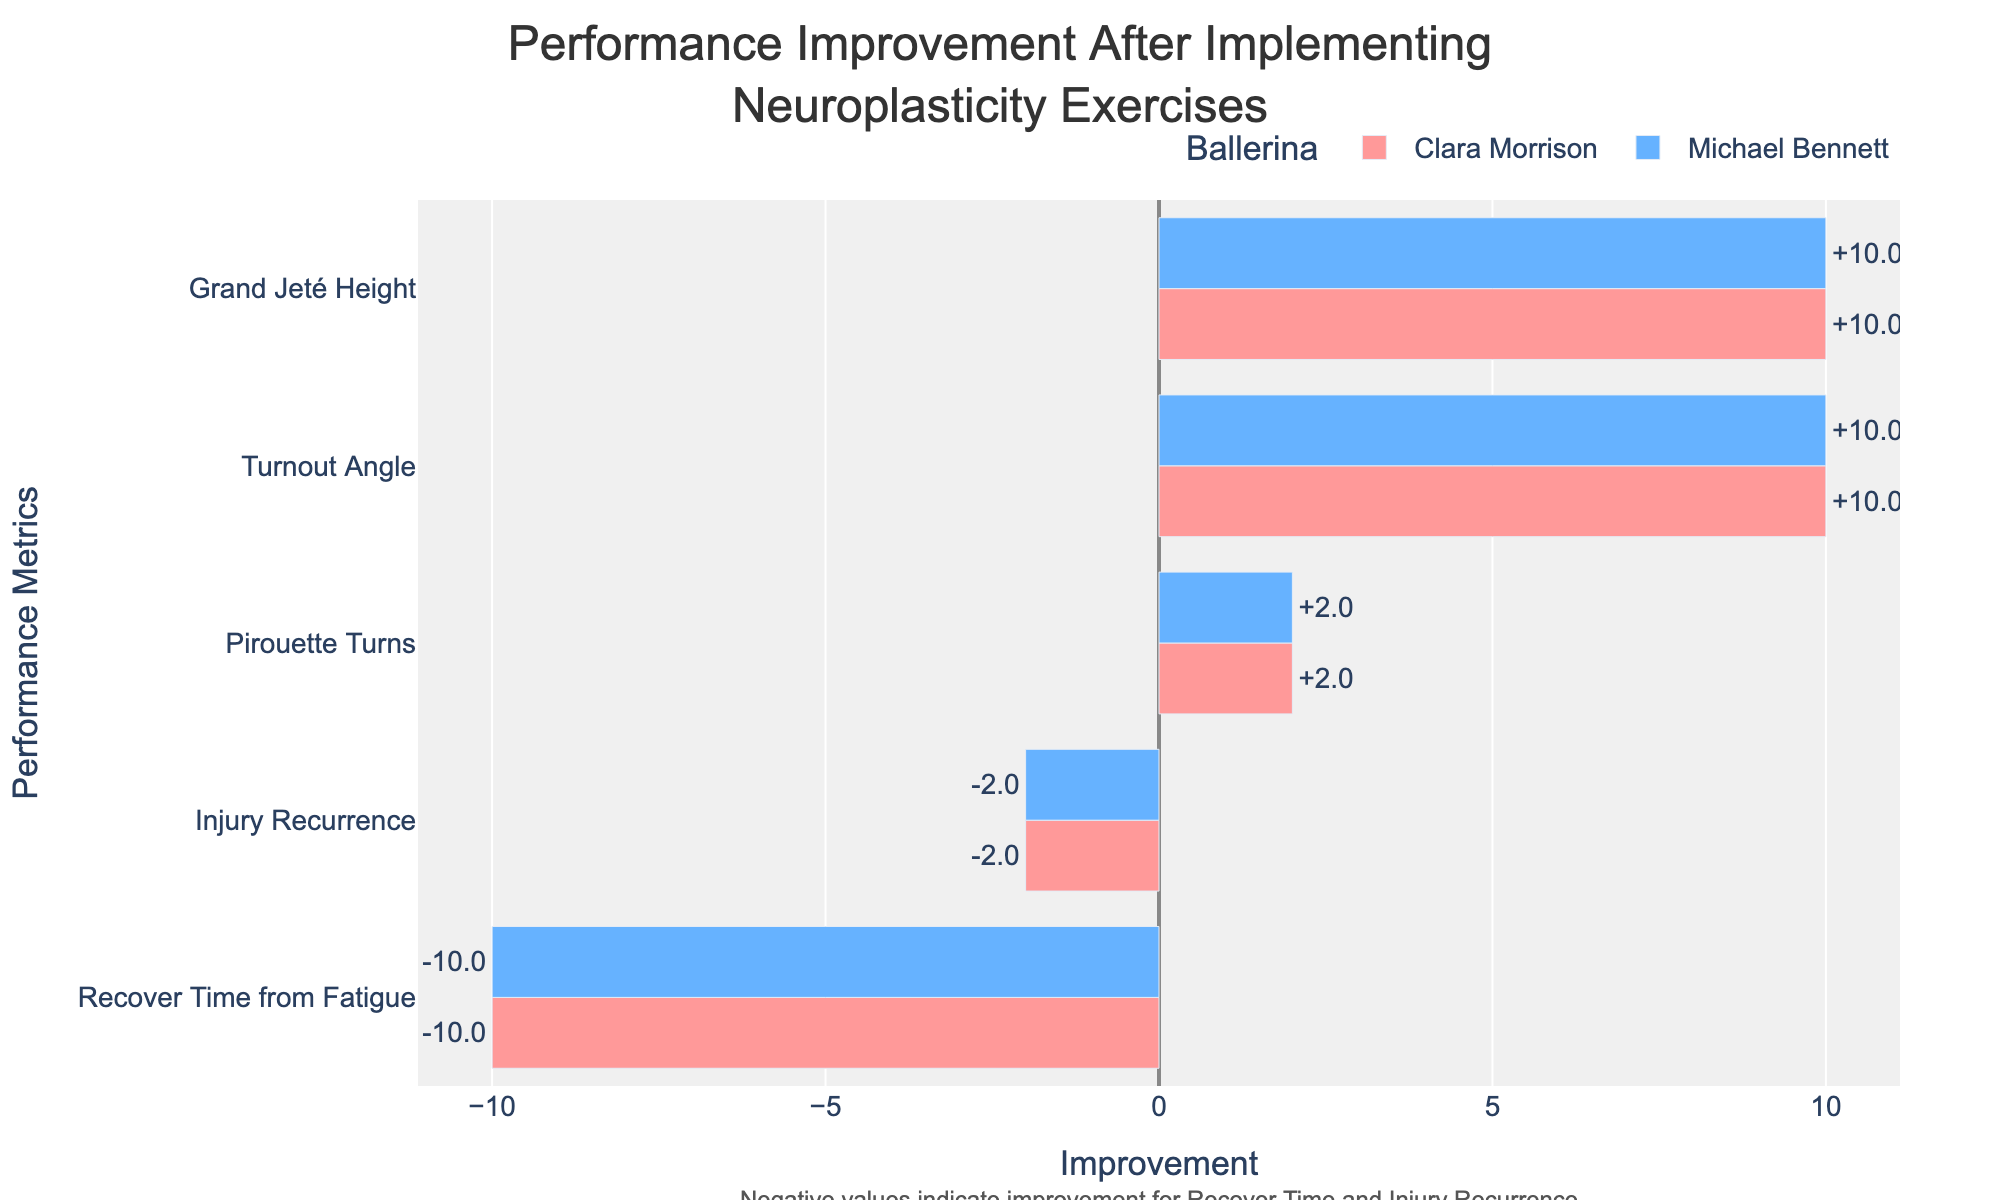Which ballerina showed the largest improvement in Turnout Angle? By looking at the difference in the Turnout Angle before and after implementing neuroplasticity exercises, Michael Bennett improved by 10 degrees (from 40 to 50 degrees), whereas Clara Morrison improved by 10 degrees (from 45 to 55 degrees). Both improved by the same amount.
Answer: Both showed the same improvement Which performance metric showed the highest average improvement for both ballerinas? Calculating the average improvement across all metrics, the Turnout Angle and Pirouette Turns both have an average improvement of 10 for Michael Bennett and Clara Morrison combined. However, the overall improvement can be seen visually by noting the highest bars.
Answer: Turnout Angle and Pirouette Turns What is the percentage improvement in Clara Morrison's Grand Jeté Height after implementing the exercises? Clara Morrison's Grand Jeté Height increased from 50 to 60. The percentage improvement is calculated as ((60 - 50) / 50) * 100 = 20%.
Answer: 20% Did Michael Bennett's recovery time from fatigue show an improvement or decline? By checking the bar chart, Michael Bennett’s recovery time from fatigue decreased from 28 to 18, indicating an improvement.
Answer: Improvement Which ballerina had a greater reduction in injury recurrence after implementing neuroplasticity exercises? Comparing the differences, Clara Morrison reduced her injury recurrence from 3 to 1, a reduction of 2 incidents. Michael Bennett reduced his injury recurrence from 4 to 2, also a reduction of 2 incidents. Both had the same reduction.
Answer: Both had the same reduction How much did Michael Bennett's Pirouette Turns improve after implementing the exercises? Michael Bennett's Pirouette Turns increased from 3 to 5. The improvement is thus 5 - 3 = 2 turns.
Answer: 2 turns Which performance metric showed the smallest improvement for Clara Morrison? By comparing the visual lengths of the bars for Clara Morrison, it is evident that the smallest improvement is in Injury Recurrence, which improved by 2 incidents.
Answer: Injury Recurrence Between Clara Morrison and Michael Bennett, who achieved a higher turnout angle after implementing the neuroplasticity exercises? The final turnout angle for Clara Morrison is 55 degrees and for Michael Bennett, it is 50 degrees. Therefore, Clara Morrison achieved a higher turnout angle.
Answer: Clara Morrison What is the total change in Clara Morrison's performance across all metrics after implementing neuroplasticity exercises? Summing the differences for Clara Morrison across all metrics: (55-45) + (4-2) + (60-50) + (30-20) + (3-1) = 10 + 2 + 10 + (-10) + (-2) = 10.
Answer: 10 How does the improvement in Clara Morrison’s Turnout Angle compare to Michael Bennett’s? Both Clara Morrison and Michael Bennett had an improvement of 10 degrees in their Turnout Angle (from 45 to 55 and from 40 to 50, respectively).
Answer: Same improvement 